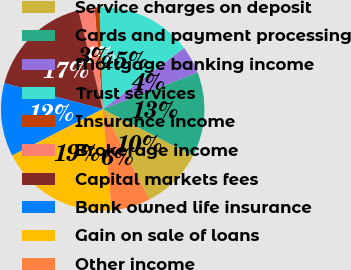Convert chart to OTSL. <chart><loc_0><loc_0><loc_500><loc_500><pie_chart><fcel>Service charges on deposit<fcel>Cards and payment processing<fcel>Mortgage banking income<fcel>Trust services<fcel>Insurance income<fcel>Brokerage income<fcel>Capital markets fees<fcel>Bank owned life insurance<fcel>Gain on sale of loans<fcel>Other income<nl><fcel>9.82%<fcel>13.44%<fcel>4.39%<fcel>15.25%<fcel>0.77%<fcel>2.58%<fcel>17.06%<fcel>11.63%<fcel>18.87%<fcel>6.2%<nl></chart> 